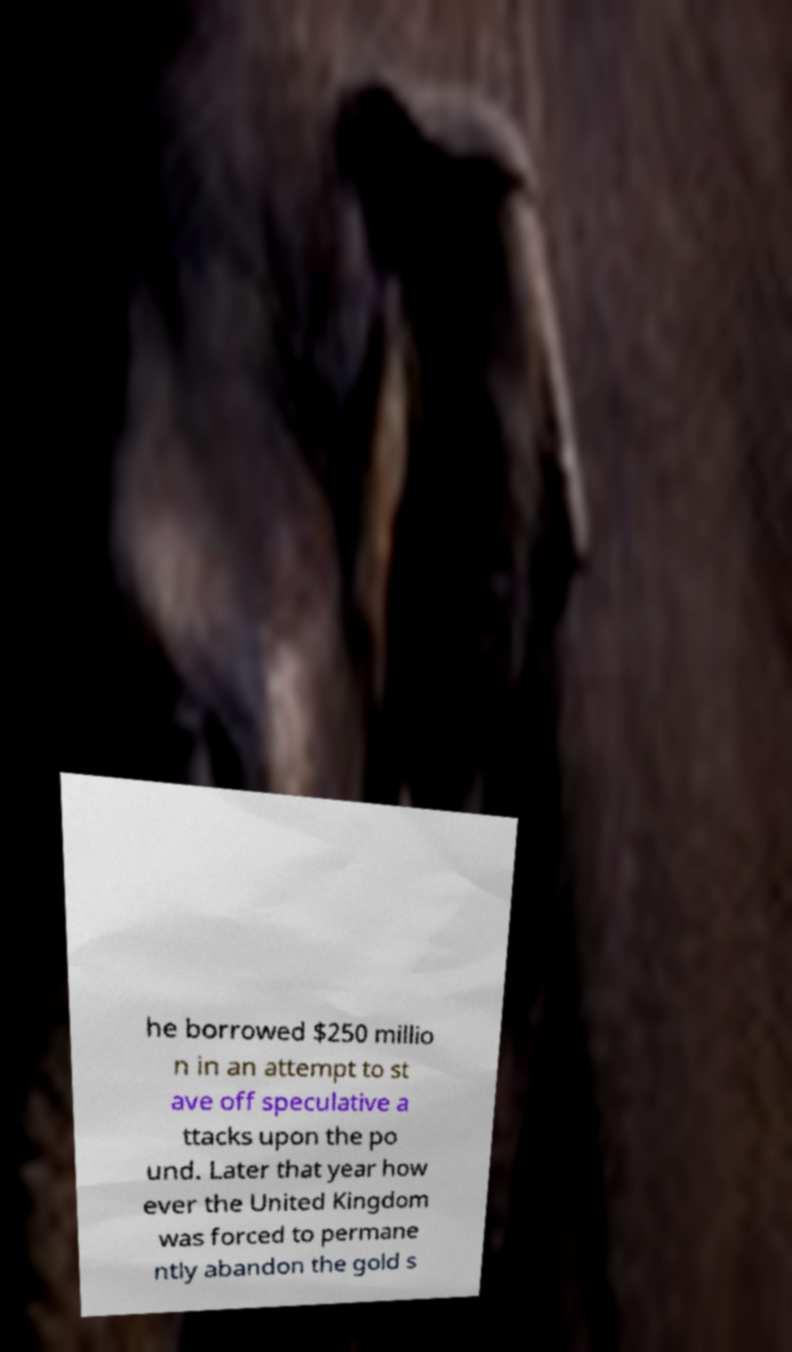Could you assist in decoding the text presented in this image and type it out clearly? he borrowed $250 millio n in an attempt to st ave off speculative a ttacks upon the po und. Later that year how ever the United Kingdom was forced to permane ntly abandon the gold s 